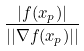Convert formula to latex. <formula><loc_0><loc_0><loc_500><loc_500>\frac { | f ( x _ { p } ) | } { | | \nabla f ( x _ { p } ) | | }</formula> 